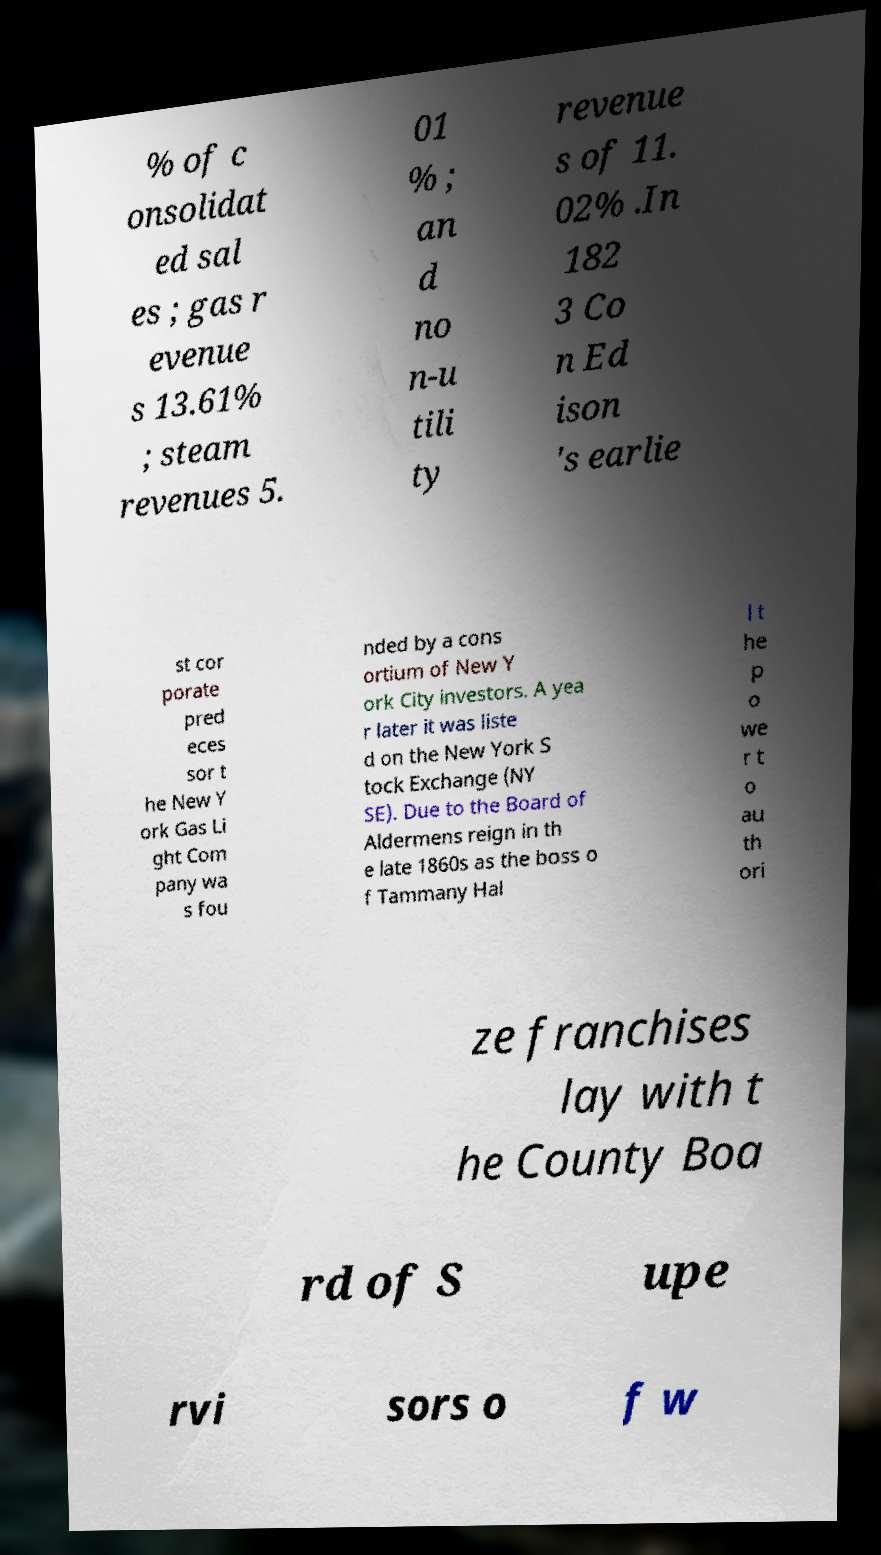Please identify and transcribe the text found in this image. % of c onsolidat ed sal es ; gas r evenue s 13.61% ; steam revenues 5. 01 % ; an d no n-u tili ty revenue s of 11. 02% .In 182 3 Co n Ed ison 's earlie st cor porate pred eces sor t he New Y ork Gas Li ght Com pany wa s fou nded by a cons ortium of New Y ork City investors. A yea r later it was liste d on the New York S tock Exchange (NY SE). Due to the Board of Aldermens reign in th e late 1860s as the boss o f Tammany Hal l t he p o we r t o au th ori ze franchises lay with t he County Boa rd of S upe rvi sors o f w 